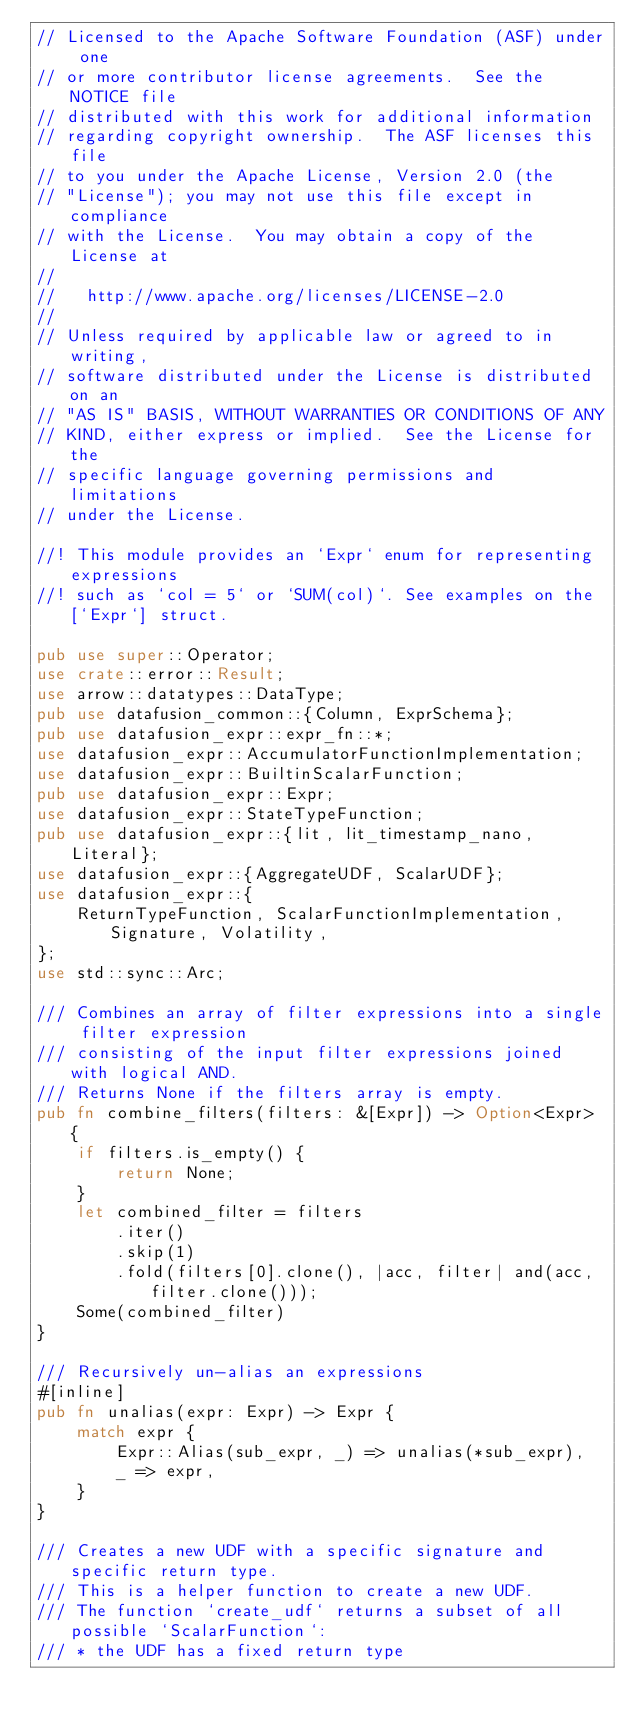<code> <loc_0><loc_0><loc_500><loc_500><_Rust_>// Licensed to the Apache Software Foundation (ASF) under one
// or more contributor license agreements.  See the NOTICE file
// distributed with this work for additional information
// regarding copyright ownership.  The ASF licenses this file
// to you under the Apache License, Version 2.0 (the
// "License"); you may not use this file except in compliance
// with the License.  You may obtain a copy of the License at
//
//   http://www.apache.org/licenses/LICENSE-2.0
//
// Unless required by applicable law or agreed to in writing,
// software distributed under the License is distributed on an
// "AS IS" BASIS, WITHOUT WARRANTIES OR CONDITIONS OF ANY
// KIND, either express or implied.  See the License for the
// specific language governing permissions and limitations
// under the License.

//! This module provides an `Expr` enum for representing expressions
//! such as `col = 5` or `SUM(col)`. See examples on the [`Expr`] struct.

pub use super::Operator;
use crate::error::Result;
use arrow::datatypes::DataType;
pub use datafusion_common::{Column, ExprSchema};
pub use datafusion_expr::expr_fn::*;
use datafusion_expr::AccumulatorFunctionImplementation;
use datafusion_expr::BuiltinScalarFunction;
pub use datafusion_expr::Expr;
use datafusion_expr::StateTypeFunction;
pub use datafusion_expr::{lit, lit_timestamp_nano, Literal};
use datafusion_expr::{AggregateUDF, ScalarUDF};
use datafusion_expr::{
    ReturnTypeFunction, ScalarFunctionImplementation, Signature, Volatility,
};
use std::sync::Arc;

/// Combines an array of filter expressions into a single filter expression
/// consisting of the input filter expressions joined with logical AND.
/// Returns None if the filters array is empty.
pub fn combine_filters(filters: &[Expr]) -> Option<Expr> {
    if filters.is_empty() {
        return None;
    }
    let combined_filter = filters
        .iter()
        .skip(1)
        .fold(filters[0].clone(), |acc, filter| and(acc, filter.clone()));
    Some(combined_filter)
}

/// Recursively un-alias an expressions
#[inline]
pub fn unalias(expr: Expr) -> Expr {
    match expr {
        Expr::Alias(sub_expr, _) => unalias(*sub_expr),
        _ => expr,
    }
}

/// Creates a new UDF with a specific signature and specific return type.
/// This is a helper function to create a new UDF.
/// The function `create_udf` returns a subset of all possible `ScalarFunction`:
/// * the UDF has a fixed return type</code> 